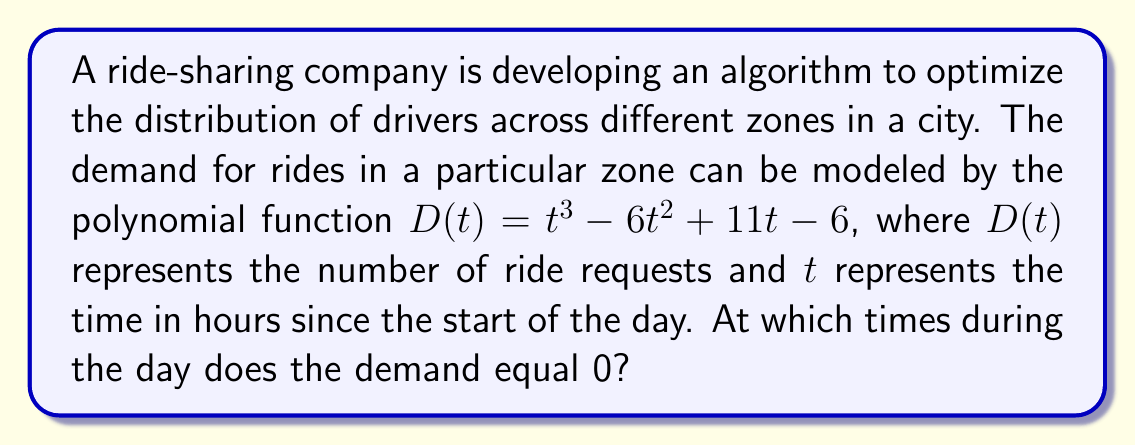Help me with this question. To solve this problem, we need to factor the polynomial $D(t) = t^3 - 6t^2 + 11t - 6$ and find its roots. These roots will represent the times when the demand is zero.

Step 1: Identify the polynomial
$D(t) = t^3 - 6t^2 + 11t - 6$

Step 2: Try to factor out a common factor
There is no common factor for all terms, so we proceed to the next step.

Step 3: Check if it's a perfect cube
It's not a perfect cube, so we'll use the rational root theorem.

Step 4: Apply the rational root theorem
Possible rational roots are factors of the constant term (6): ±1, ±2, ±3, ±6

Step 5: Test these potential roots
We find that $t = 1$ is a root of the polynomial.

Step 6: Factor out $(t - 1)$
$D(t) = (t - 1)(t^2 - 5t + 6)$

Step 7: Factor the quadratic term
$D(t) = (t - 1)(t - 2)(t - 3)$

Step 8: Solve for $D(t) = 0$
$D(t) = 0$ when $t = 1$, $t = 2$, or $t = 3$

Therefore, the demand equals 0 at 1 hour, 2 hours, and 3 hours after the start of the day.
Answer: 1, 2, and 3 hours after the start of the day 